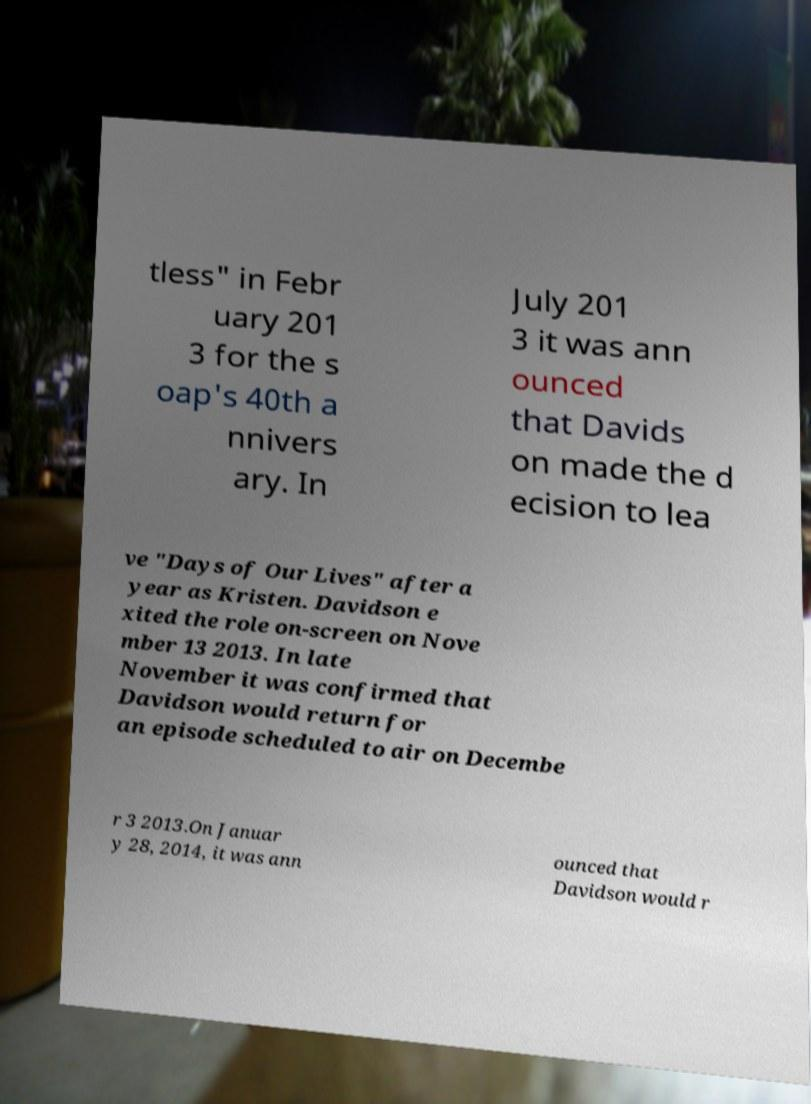Please read and relay the text visible in this image. What does it say? tless" in Febr uary 201 3 for the s oap's 40th a nnivers ary. In July 201 3 it was ann ounced that Davids on made the d ecision to lea ve "Days of Our Lives" after a year as Kristen. Davidson e xited the role on-screen on Nove mber 13 2013. In late November it was confirmed that Davidson would return for an episode scheduled to air on Decembe r 3 2013.On Januar y 28, 2014, it was ann ounced that Davidson would r 